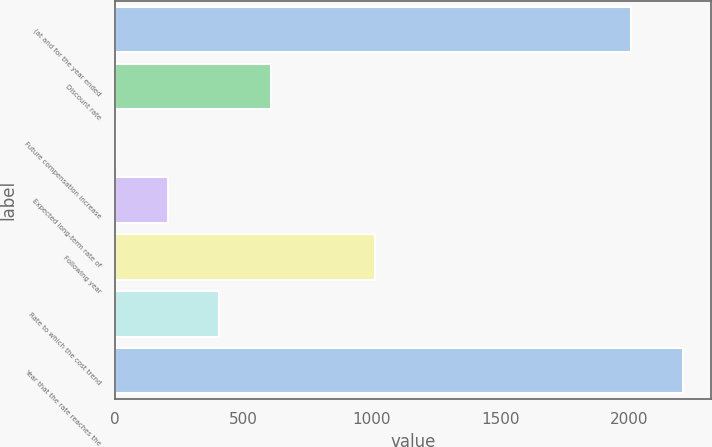<chart> <loc_0><loc_0><loc_500><loc_500><bar_chart><fcel>(at and for the year ended<fcel>Discount rate<fcel>Future compensation increase<fcel>Expected long-term rate of<fcel>Following year<fcel>Rate to which the cost trend<fcel>Year that the rate reaches the<nl><fcel>2009<fcel>607.9<fcel>4<fcel>205.3<fcel>1010.5<fcel>406.6<fcel>2210.3<nl></chart> 